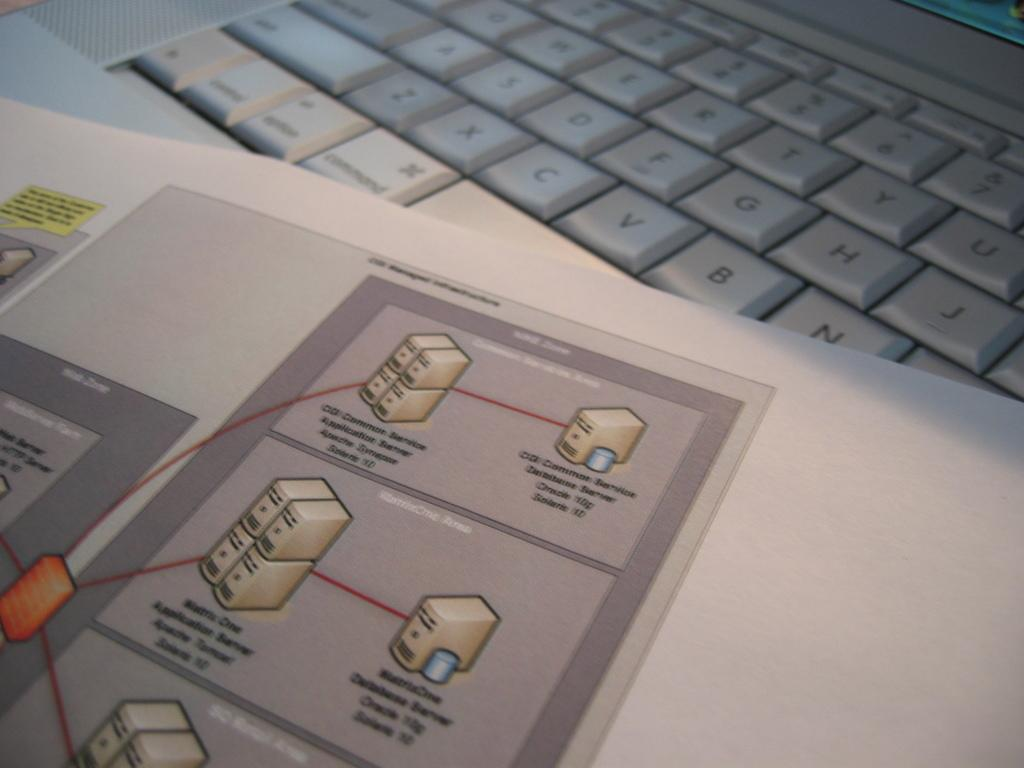What is the main object in the image that appears to be white? There is a white paper or book in the image. What is depicted on the white paper or book? A drawing is visible on the paper or book. What other object in the image is also white? There is a white keyboard in the image. What type of clouds can be seen in the image? There are no clouds present in the image; it features a white paper or book with a drawing, a white keyboard, and no mention of clouds. Is there a train visible in the image? There is no train present in the image; it only features a white paper or book with a drawing, a white keyboard, and no mention of a train. 